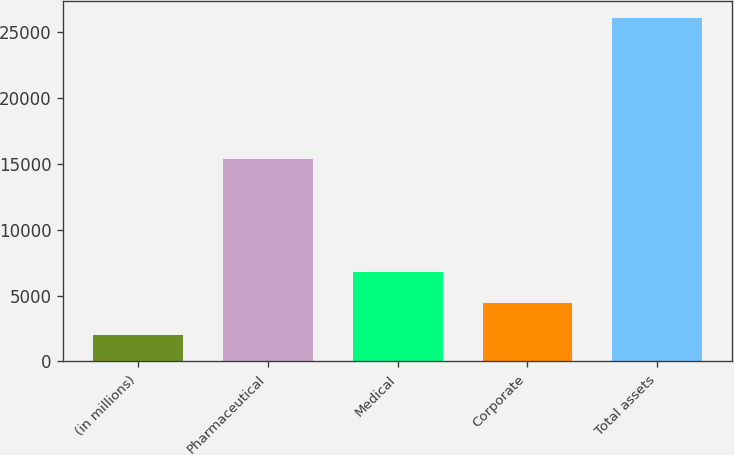Convert chart. <chart><loc_0><loc_0><loc_500><loc_500><bar_chart><fcel>(in millions)<fcel>Pharmaceutical<fcel>Medical<fcel>Corporate<fcel>Total assets<nl><fcel>2014<fcel>15361<fcel>6817.8<fcel>4415.9<fcel>26033<nl></chart> 